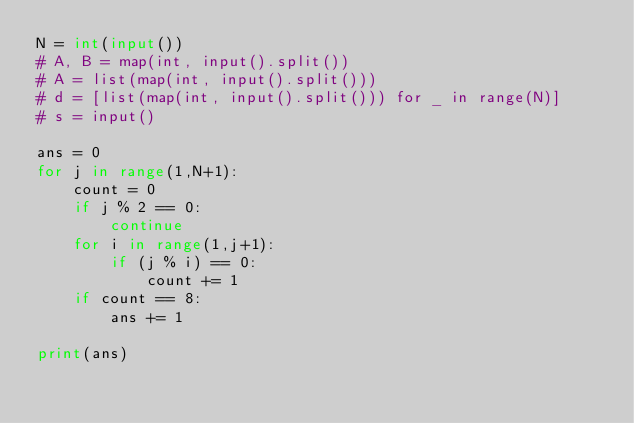Convert code to text. <code><loc_0><loc_0><loc_500><loc_500><_Python_>N = int(input())
# A, B = map(int, input().split())
# A = list(map(int, input().split()))
# d = [list(map(int, input().split())) for _ in range(N)]
# s = input()

ans = 0
for j in range(1,N+1):
    count = 0
    if j % 2 == 0:
        continue
    for i in range(1,j+1):
        if (j % i) == 0:
            count += 1
    if count == 8:
        ans += 1

print(ans)</code> 